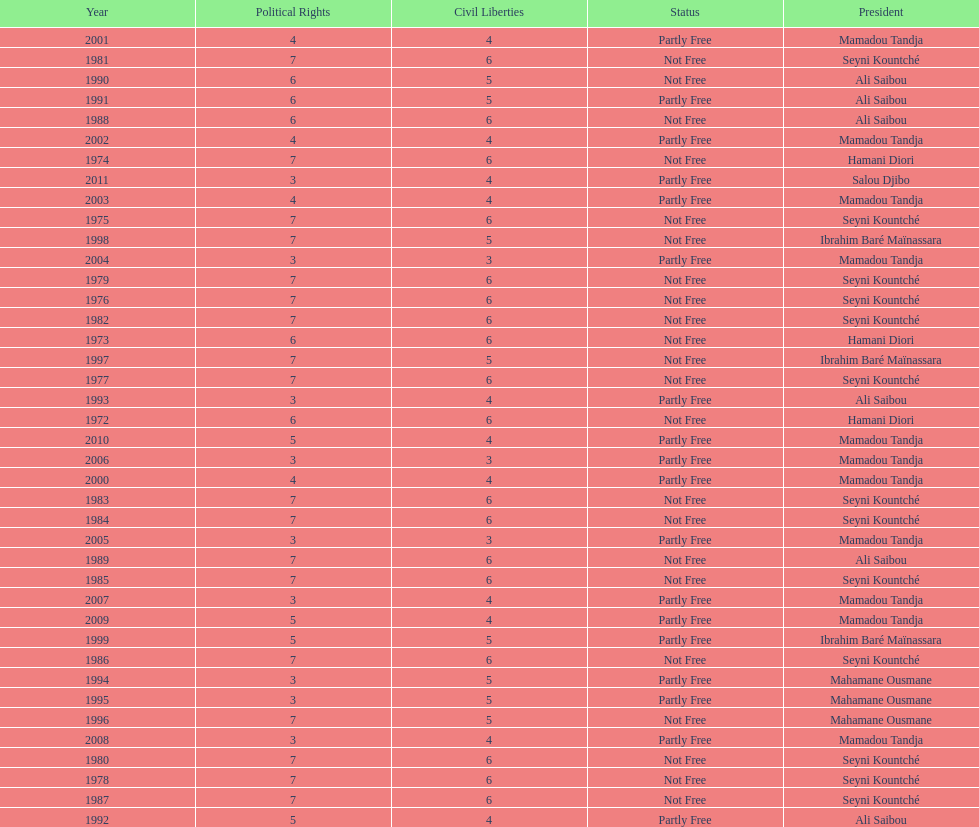Who was president before mamadou tandja? Ibrahim Baré Maïnassara. 